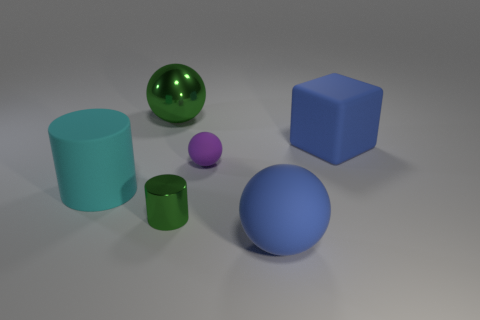Add 3 yellow metallic spheres. How many objects exist? 9 Subtract all cylinders. How many objects are left? 4 Subtract all large gray matte spheres. Subtract all big blue matte blocks. How many objects are left? 5 Add 3 large blue cubes. How many large blue cubes are left? 4 Add 2 big yellow shiny blocks. How many big yellow shiny blocks exist? 2 Subtract 0 red cylinders. How many objects are left? 6 